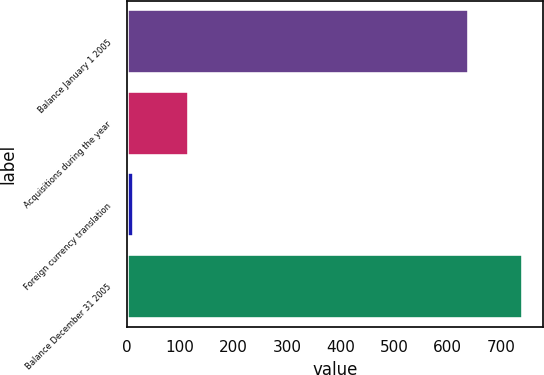Convert chart to OTSL. <chart><loc_0><loc_0><loc_500><loc_500><bar_chart><fcel>Balance January 1 2005<fcel>Acquisitions during the year<fcel>Foreign currency translation<fcel>Balance December 31 2005<nl><fcel>639.2<fcel>117.2<fcel>13.6<fcel>740.9<nl></chart> 